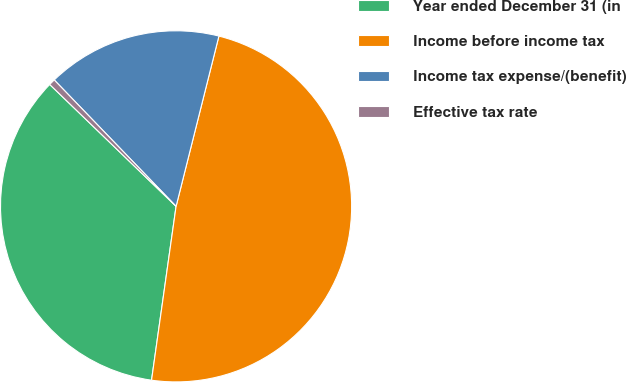<chart> <loc_0><loc_0><loc_500><loc_500><pie_chart><fcel>Year ended December 31 (in<fcel>Income before income tax<fcel>Income tax expense/(benefit)<fcel>Effective tax rate<nl><fcel>34.98%<fcel>48.31%<fcel>16.13%<fcel>0.58%<nl></chart> 